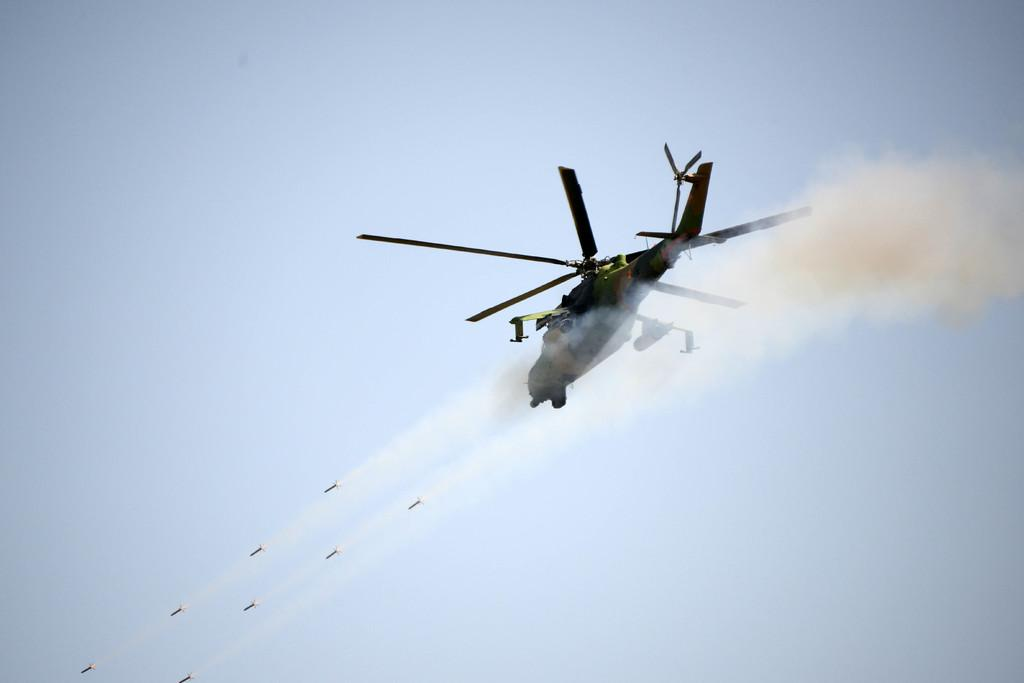What is the main subject of the image? The main subject of the image is a flight. What is the flight doing in the image? The flight is flying in the air. What can be seen coming from the flight in the image? Fumes are visible in the image. What type of brush is being used by the door porter in the image? There is no door porter or brush present in the image. What type of door can be seen in the image? There is no door present in the image; it features a flight flying in the air. 